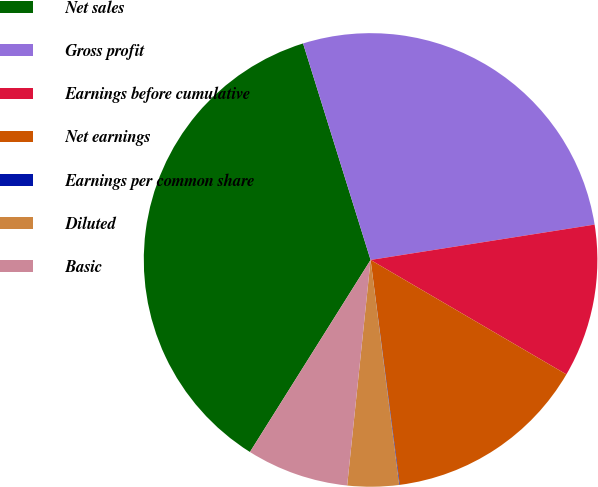<chart> <loc_0><loc_0><loc_500><loc_500><pie_chart><fcel>Net sales<fcel>Gross profit<fcel>Earnings before cumulative<fcel>Net earnings<fcel>Earnings per common share<fcel>Diluted<fcel>Basic<nl><fcel>36.26%<fcel>27.32%<fcel>10.91%<fcel>14.53%<fcel>0.04%<fcel>3.66%<fcel>7.28%<nl></chart> 